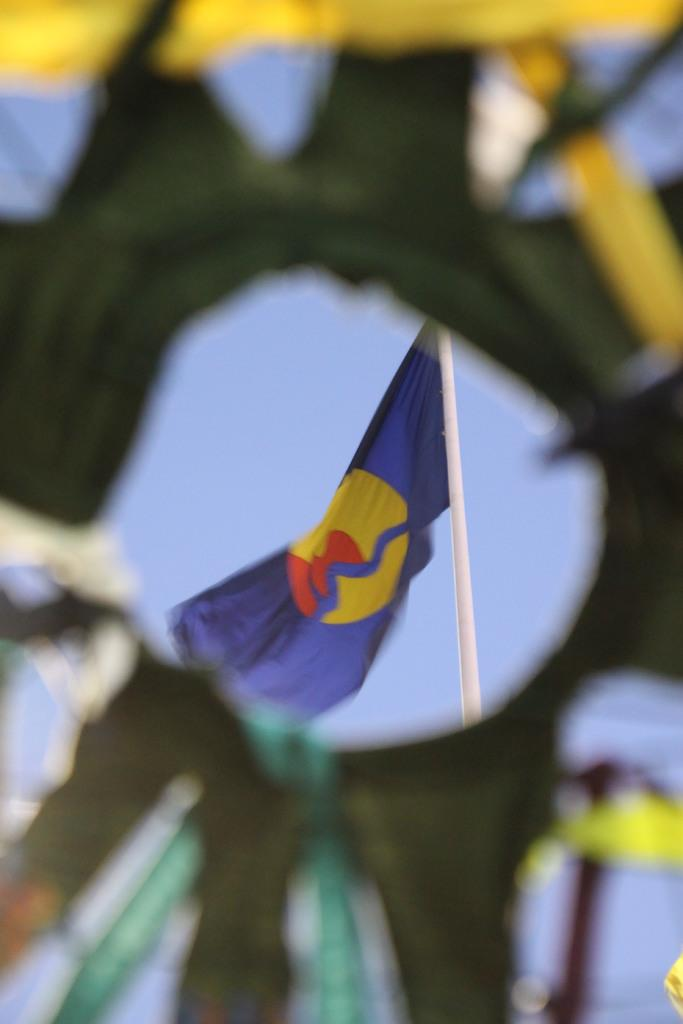What is located on the pole in the image? There is a flag on a pole in the image. What is positioned in front of the pole in the image? Unfortunately, the provided facts do not give enough information to answer this question definitively. What type of animal can be seen casting a development spell in the image? There is no animal or any indication of a spell being cast in the image. 